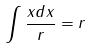<formula> <loc_0><loc_0><loc_500><loc_500>\int \frac { x d x } { r } = r</formula> 